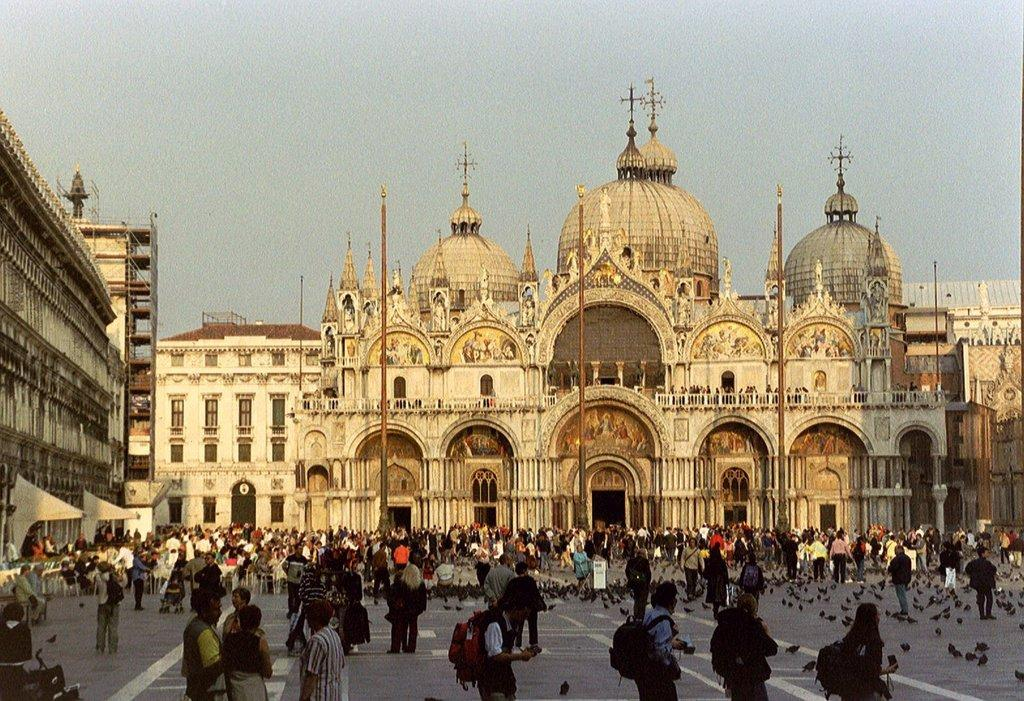What type of structures can be seen in the image? There are buildings in the image. What architectural features are present on the buildings? There are windows in the image. What other objects can be seen in the image? There are poles in the image. What is the activity of the people in the image? There are people walking in the image. What type of animals are present in the image? There are birds in the image. What part of the natural environment is visible in the image? The sky is visible in the image. What type of cake is being served at the event in the image? There is no event or cake present in the image. Can you see any stars in the sky in the image? The sky is visible in the image, but there are no stars present. 